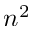<formula> <loc_0><loc_0><loc_500><loc_500>n ^ { 2 }</formula> 